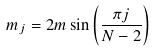Convert formula to latex. <formula><loc_0><loc_0><loc_500><loc_500>m _ { j } = 2 m \, { \sin \left ( \frac { \pi j } { N - 2 } \right ) }</formula> 